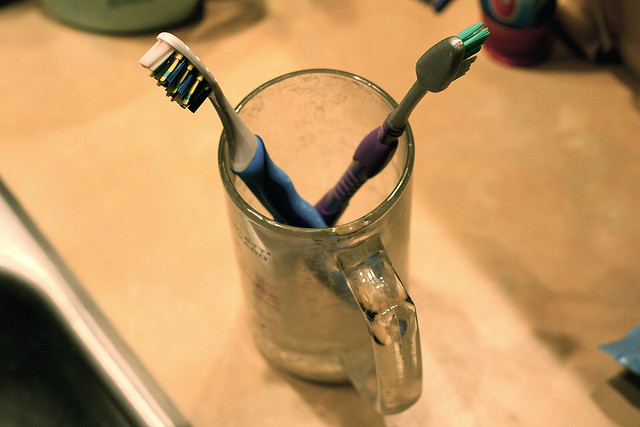<image>What figure is on the glass? I cannot tell what figure is on the glass as it isn't clearly visible. What figure is on the glass? I am not sure what figure is on the glass. It can be seen 'round', 'cross', 'mug', 'circle' or 'toothbrush'. 